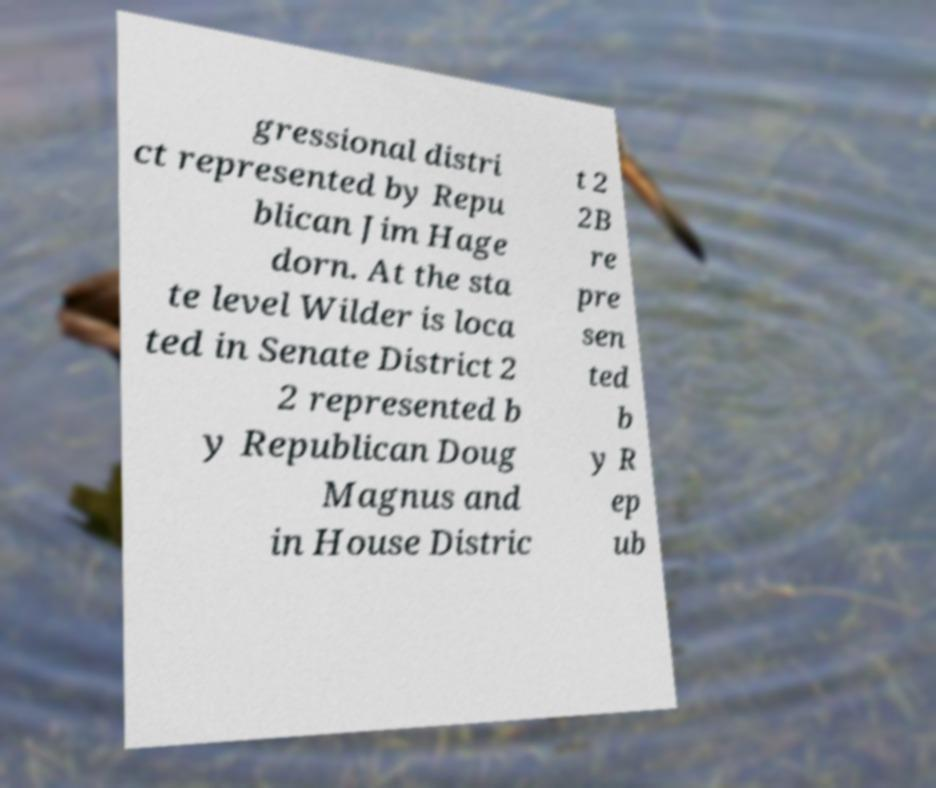Could you extract and type out the text from this image? gressional distri ct represented by Repu blican Jim Hage dorn. At the sta te level Wilder is loca ted in Senate District 2 2 represented b y Republican Doug Magnus and in House Distric t 2 2B re pre sen ted b y R ep ub 